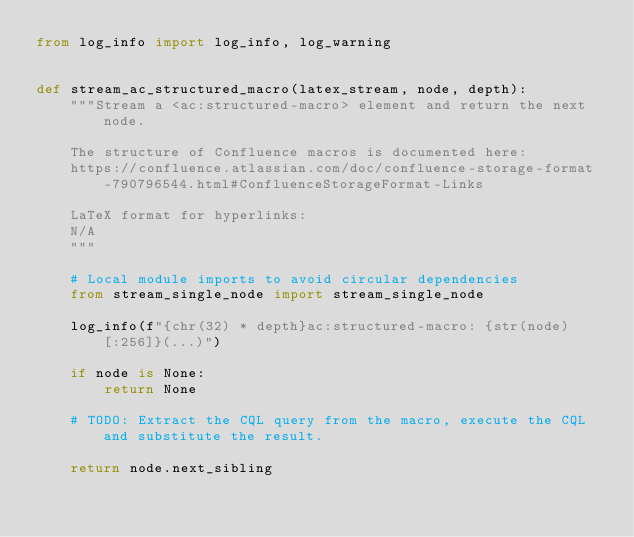Convert code to text. <code><loc_0><loc_0><loc_500><loc_500><_Python_>from log_info import log_info, log_warning


def stream_ac_structured_macro(latex_stream, node, depth):
    """Stream a <ac:structured-macro> element and return the next node.

    The structure of Confluence macros is documented here:
    https://confluence.atlassian.com/doc/confluence-storage-format-790796544.html#ConfluenceStorageFormat-Links

    LaTeX format for hyperlinks:
    N/A
    """

    # Local module imports to avoid circular dependencies
    from stream_single_node import stream_single_node

    log_info(f"{chr(32) * depth}ac:structured-macro: {str(node)[:256]}(...)")

    if node is None:
        return None

    # TODO: Extract the CQL query from the macro, execute the CQL and substitute the result.

    return node.next_sibling
</code> 